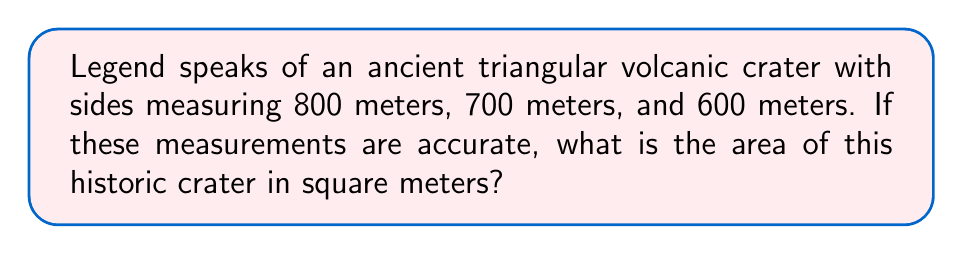Can you solve this math problem? To find the area of a triangle when we know the lengths of all three sides, we can use Heron's formula. Let's follow these steps:

1) First, recall Heron's formula:
   $$A = \sqrt{s(s-a)(s-b)(s-c)}$$
   where $A$ is the area, $a$, $b$, and $c$ are the side lengths, and $s$ is the semi-perimeter.

2) Calculate the semi-perimeter $s$:
   $$s = \frac{a + b + c}{2} = \frac{800 + 700 + 600}{2} = \frac{2100}{2} = 1050$$

3) Now, substitute all values into Heron's formula:
   $$A = \sqrt{1050(1050-800)(1050-700)(1050-600)}$$
   $$A = \sqrt{1050 \cdot 250 \cdot 350 \cdot 450}$$

4) Multiply the values under the square root:
   $$A = \sqrt{41,343,750,000}$$

5) Calculate the square root:
   $$A = 203,330.29...$$

6) Round to the nearest whole number as we're dealing with meters:
   $$A \approx 203,330 \text{ m}^2$$

Thus, the area of the triangular volcanic crater is approximately 203,330 square meters.
Answer: $203,330 \text{ m}^2$ 